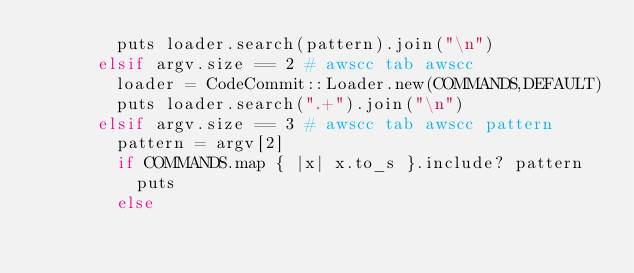Convert code to text. <code><loc_0><loc_0><loc_500><loc_500><_Ruby_>        puts loader.search(pattern).join("\n")
      elsif argv.size == 2 # awscc tab awscc
        loader = CodeCommit::Loader.new(COMMANDS,DEFAULT)
        puts loader.search(".+").join("\n")
      elsif argv.size == 3 # awscc tab awscc pattern
        pattern = argv[2]
        if COMMANDS.map { |x| x.to_s }.include? pattern
          puts
        else</code> 